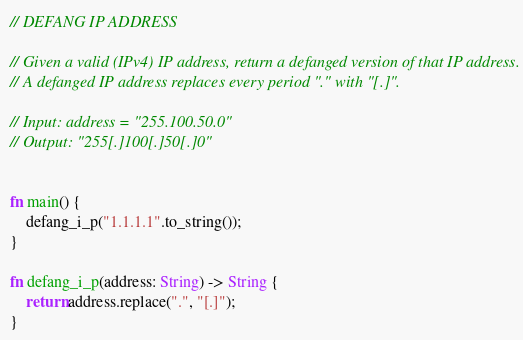<code> <loc_0><loc_0><loc_500><loc_500><_Rust_>

// DEFANG IP ADDRESS

// Given a valid (IPv4) IP address, return a defanged version of that IP address.
// A defanged IP address replaces every period "." with "[.]".

// Input: address = "255.100.50.0"
// Output: "255[.]100[.]50[.]0"


fn main() {
    defang_i_p("1.1.1.1".to_string());
}

fn defang_i_p(address: String) -> String {
    return address.replace(".", "[.]");
}

</code> 